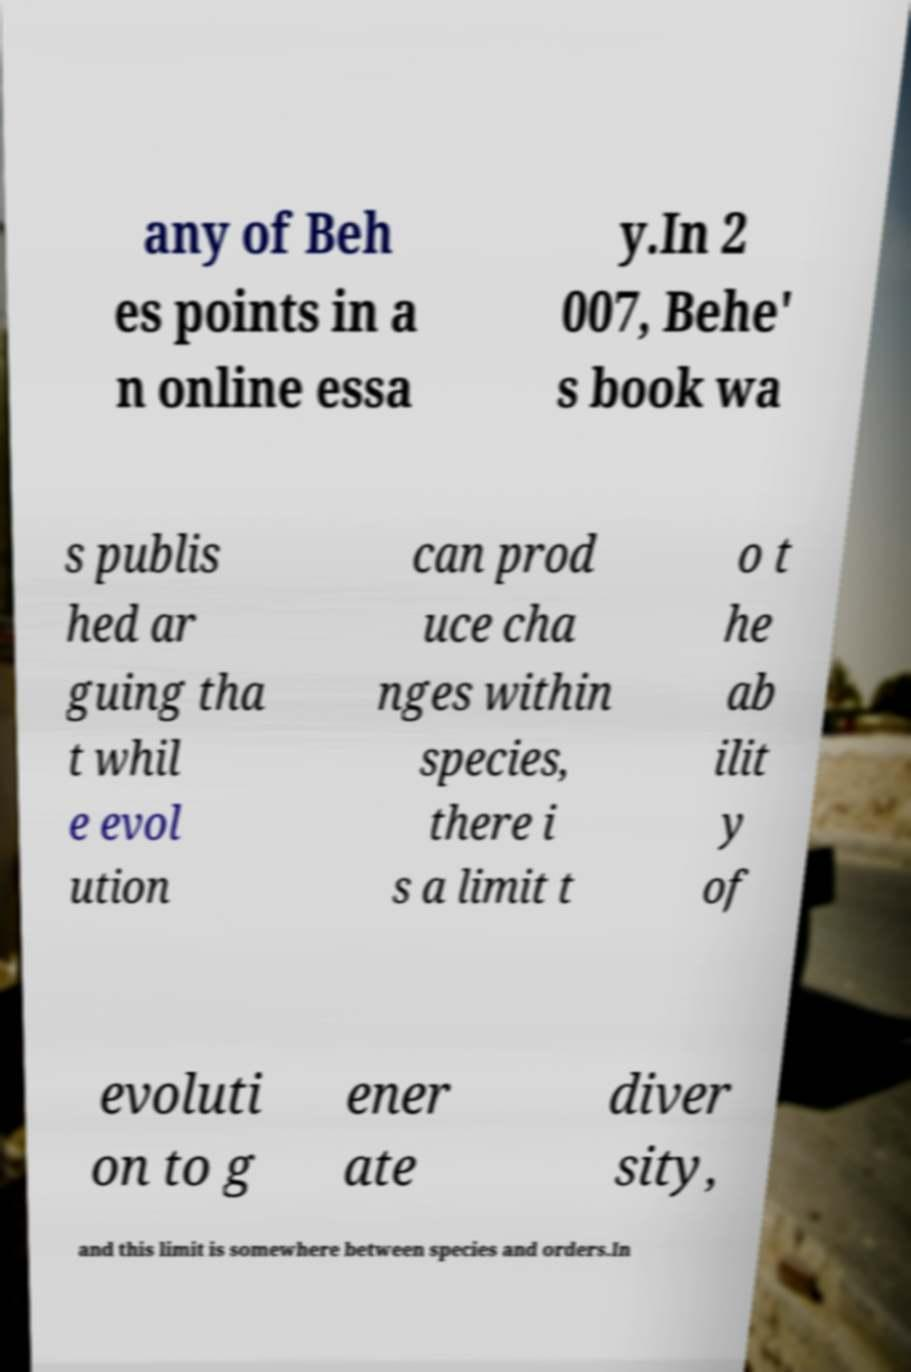Could you assist in decoding the text presented in this image and type it out clearly? any of Beh es points in a n online essa y.In 2 007, Behe' s book wa s publis hed ar guing tha t whil e evol ution can prod uce cha nges within species, there i s a limit t o t he ab ilit y of evoluti on to g ener ate diver sity, and this limit is somewhere between species and orders.In 